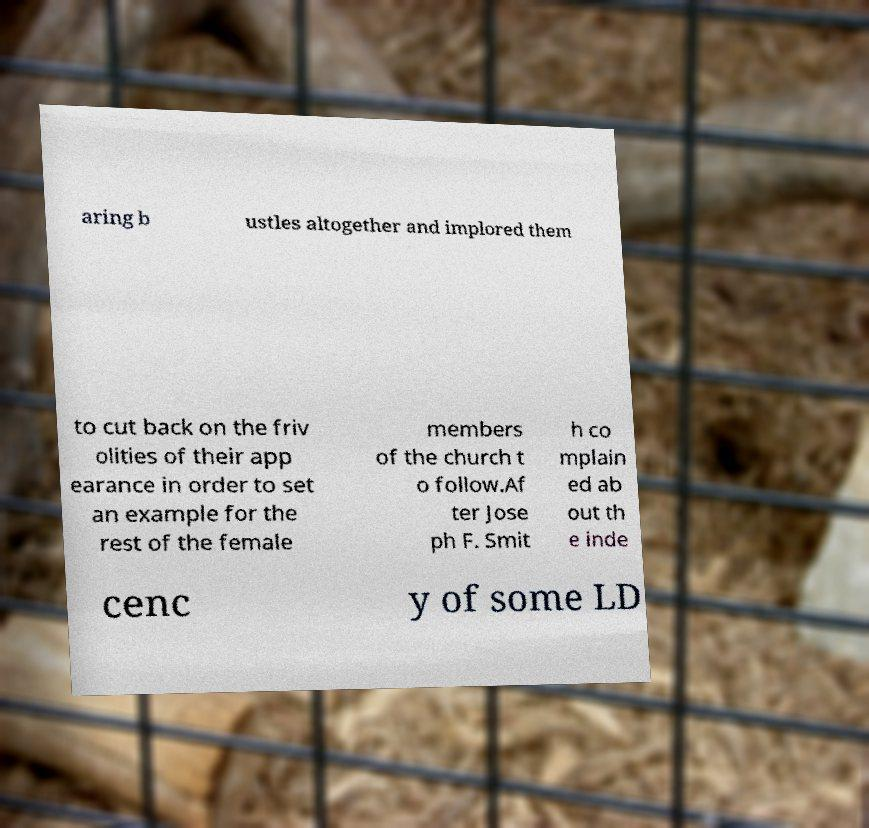Can you accurately transcribe the text from the provided image for me? aring b ustles altogether and implored them to cut back on the friv olities of their app earance in order to set an example for the rest of the female members of the church t o follow.Af ter Jose ph F. Smit h co mplain ed ab out th e inde cenc y of some LD 